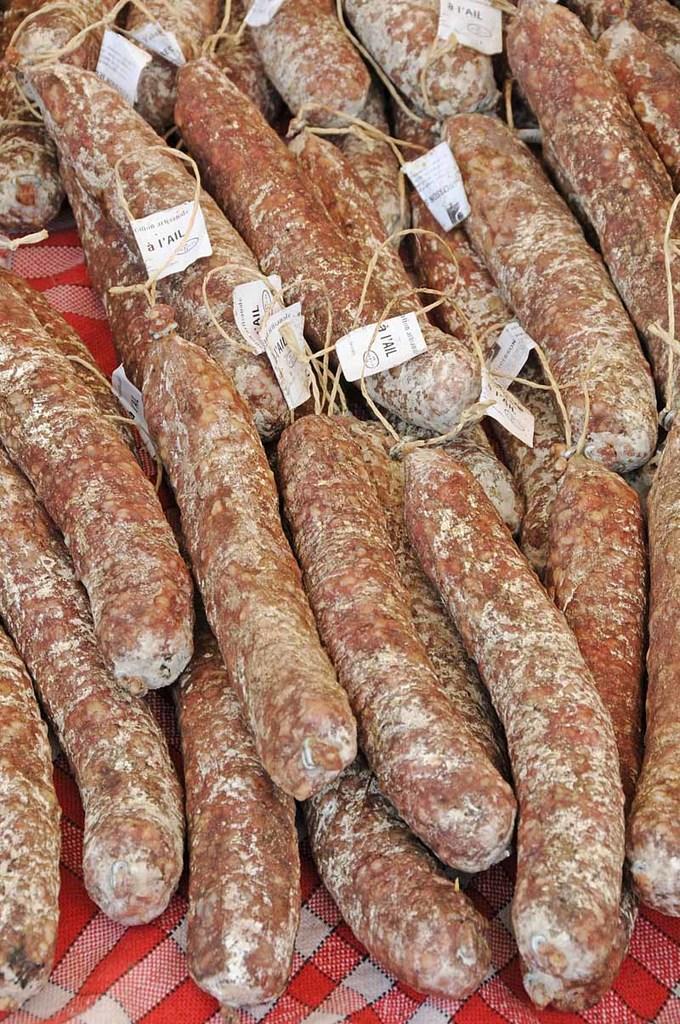Describe this image in one or two sentences. In this picture I can see there is food placed on the napkin and it has some tags attached to the food. 